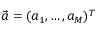<formula> <loc_0><loc_0><loc_500><loc_500>\vec { a } = ( a _ { 1 } , \dots , a _ { M } ) ^ { T }</formula> 